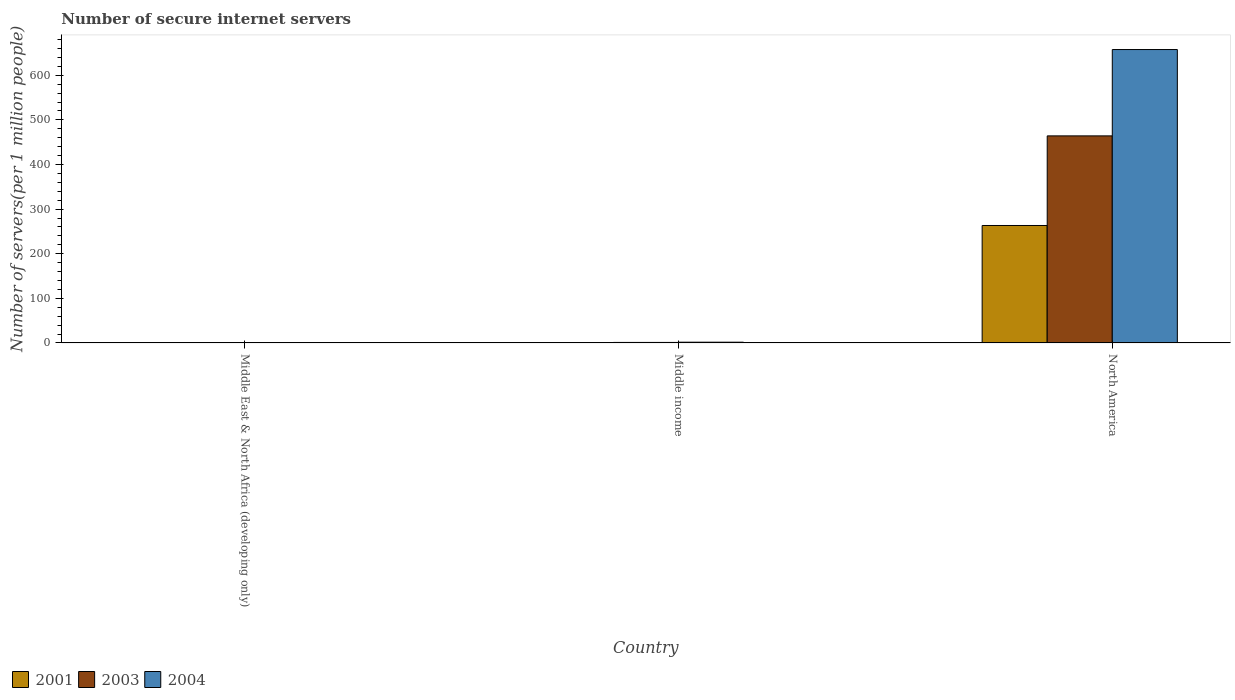What is the label of the 1st group of bars from the left?
Keep it short and to the point. Middle East & North Africa (developing only). In how many cases, is the number of bars for a given country not equal to the number of legend labels?
Your response must be concise. 0. What is the number of secure internet servers in 2004 in North America?
Give a very brief answer. 657.56. Across all countries, what is the maximum number of secure internet servers in 2004?
Offer a terse response. 657.56. Across all countries, what is the minimum number of secure internet servers in 2003?
Offer a terse response. 0.32. In which country was the number of secure internet servers in 2004 maximum?
Make the answer very short. North America. In which country was the number of secure internet servers in 2004 minimum?
Ensure brevity in your answer.  Middle East & North Africa (developing only). What is the total number of secure internet servers in 2001 in the graph?
Your answer should be compact. 264.23. What is the difference between the number of secure internet servers in 2004 in Middle income and that in North America?
Your response must be concise. -655.89. What is the difference between the number of secure internet servers in 2001 in Middle income and the number of secure internet servers in 2003 in North America?
Give a very brief answer. -463.3. What is the average number of secure internet servers in 2003 per country?
Give a very brief answer. 155.18. What is the difference between the number of secure internet servers of/in 2004 and number of secure internet servers of/in 2001 in Middle East & North Africa (developing only)?
Ensure brevity in your answer.  0.37. In how many countries, is the number of secure internet servers in 2004 greater than 200?
Your answer should be compact. 1. What is the ratio of the number of secure internet servers in 2003 in Middle income to that in North America?
Make the answer very short. 0. Is the number of secure internet servers in 2004 in Middle East & North Africa (developing only) less than that in North America?
Make the answer very short. Yes. Is the difference between the number of secure internet servers in 2004 in Middle income and North America greater than the difference between the number of secure internet servers in 2001 in Middle income and North America?
Your answer should be compact. No. What is the difference between the highest and the second highest number of secure internet servers in 2004?
Give a very brief answer. -656.98. What is the difference between the highest and the lowest number of secure internet servers in 2004?
Keep it short and to the point. 656.98. In how many countries, is the number of secure internet servers in 2004 greater than the average number of secure internet servers in 2004 taken over all countries?
Provide a short and direct response. 1. Is the sum of the number of secure internet servers in 2001 in Middle East & North Africa (developing only) and North America greater than the maximum number of secure internet servers in 2004 across all countries?
Offer a very short reply. No. What does the 1st bar from the left in Middle income represents?
Provide a short and direct response. 2001. What does the 1st bar from the right in Middle income represents?
Provide a short and direct response. 2004. How many bars are there?
Your response must be concise. 9. Are the values on the major ticks of Y-axis written in scientific E-notation?
Your answer should be compact. No. How many legend labels are there?
Ensure brevity in your answer.  3. What is the title of the graph?
Your answer should be compact. Number of secure internet servers. What is the label or title of the X-axis?
Keep it short and to the point. Country. What is the label or title of the Y-axis?
Keep it short and to the point. Number of servers(per 1 million people). What is the Number of servers(per 1 million people) in 2001 in Middle East & North Africa (developing only)?
Your response must be concise. 0.21. What is the Number of servers(per 1 million people) of 2003 in Middle East & North Africa (developing only)?
Your answer should be compact. 0.32. What is the Number of servers(per 1 million people) of 2004 in Middle East & North Africa (developing only)?
Your response must be concise. 0.58. What is the Number of servers(per 1 million people) in 2001 in Middle income?
Your answer should be compact. 0.78. What is the Number of servers(per 1 million people) in 2003 in Middle income?
Ensure brevity in your answer.  1.15. What is the Number of servers(per 1 million people) in 2004 in Middle income?
Provide a short and direct response. 1.67. What is the Number of servers(per 1 million people) in 2001 in North America?
Your answer should be very brief. 263.23. What is the Number of servers(per 1 million people) of 2003 in North America?
Keep it short and to the point. 464.07. What is the Number of servers(per 1 million people) of 2004 in North America?
Give a very brief answer. 657.56. Across all countries, what is the maximum Number of servers(per 1 million people) of 2001?
Make the answer very short. 263.23. Across all countries, what is the maximum Number of servers(per 1 million people) of 2003?
Make the answer very short. 464.07. Across all countries, what is the maximum Number of servers(per 1 million people) in 2004?
Ensure brevity in your answer.  657.56. Across all countries, what is the minimum Number of servers(per 1 million people) in 2001?
Your response must be concise. 0.21. Across all countries, what is the minimum Number of servers(per 1 million people) in 2003?
Ensure brevity in your answer.  0.32. Across all countries, what is the minimum Number of servers(per 1 million people) of 2004?
Provide a succinct answer. 0.58. What is the total Number of servers(per 1 million people) in 2001 in the graph?
Your response must be concise. 264.23. What is the total Number of servers(per 1 million people) of 2003 in the graph?
Your response must be concise. 465.54. What is the total Number of servers(per 1 million people) of 2004 in the graph?
Provide a short and direct response. 659.82. What is the difference between the Number of servers(per 1 million people) of 2001 in Middle East & North Africa (developing only) and that in Middle income?
Your answer should be compact. -0.56. What is the difference between the Number of servers(per 1 million people) in 2003 in Middle East & North Africa (developing only) and that in Middle income?
Make the answer very short. -0.83. What is the difference between the Number of servers(per 1 million people) of 2004 in Middle East & North Africa (developing only) and that in Middle income?
Your response must be concise. -1.09. What is the difference between the Number of servers(per 1 million people) in 2001 in Middle East & North Africa (developing only) and that in North America?
Provide a succinct answer. -263.02. What is the difference between the Number of servers(per 1 million people) of 2003 in Middle East & North Africa (developing only) and that in North America?
Keep it short and to the point. -463.76. What is the difference between the Number of servers(per 1 million people) of 2004 in Middle East & North Africa (developing only) and that in North America?
Keep it short and to the point. -656.98. What is the difference between the Number of servers(per 1 million people) of 2001 in Middle income and that in North America?
Provide a succinct answer. -262.46. What is the difference between the Number of servers(per 1 million people) in 2003 in Middle income and that in North America?
Give a very brief answer. -462.93. What is the difference between the Number of servers(per 1 million people) of 2004 in Middle income and that in North America?
Make the answer very short. -655.89. What is the difference between the Number of servers(per 1 million people) of 2001 in Middle East & North Africa (developing only) and the Number of servers(per 1 million people) of 2003 in Middle income?
Your answer should be compact. -0.93. What is the difference between the Number of servers(per 1 million people) in 2001 in Middle East & North Africa (developing only) and the Number of servers(per 1 million people) in 2004 in Middle income?
Provide a succinct answer. -1.46. What is the difference between the Number of servers(per 1 million people) of 2003 in Middle East & North Africa (developing only) and the Number of servers(per 1 million people) of 2004 in Middle income?
Keep it short and to the point. -1.35. What is the difference between the Number of servers(per 1 million people) in 2001 in Middle East & North Africa (developing only) and the Number of servers(per 1 million people) in 2003 in North America?
Keep it short and to the point. -463.86. What is the difference between the Number of servers(per 1 million people) of 2001 in Middle East & North Africa (developing only) and the Number of servers(per 1 million people) of 2004 in North America?
Offer a very short reply. -657.35. What is the difference between the Number of servers(per 1 million people) in 2003 in Middle East & North Africa (developing only) and the Number of servers(per 1 million people) in 2004 in North America?
Provide a short and direct response. -657.25. What is the difference between the Number of servers(per 1 million people) in 2001 in Middle income and the Number of servers(per 1 million people) in 2003 in North America?
Provide a short and direct response. -463.3. What is the difference between the Number of servers(per 1 million people) of 2001 in Middle income and the Number of servers(per 1 million people) of 2004 in North America?
Your answer should be very brief. -656.79. What is the difference between the Number of servers(per 1 million people) of 2003 in Middle income and the Number of servers(per 1 million people) of 2004 in North America?
Offer a very short reply. -656.42. What is the average Number of servers(per 1 million people) in 2001 per country?
Your answer should be compact. 88.08. What is the average Number of servers(per 1 million people) in 2003 per country?
Your response must be concise. 155.18. What is the average Number of servers(per 1 million people) of 2004 per country?
Give a very brief answer. 219.94. What is the difference between the Number of servers(per 1 million people) of 2001 and Number of servers(per 1 million people) of 2003 in Middle East & North Africa (developing only)?
Provide a succinct answer. -0.1. What is the difference between the Number of servers(per 1 million people) of 2001 and Number of servers(per 1 million people) of 2004 in Middle East & North Africa (developing only)?
Ensure brevity in your answer.  -0.37. What is the difference between the Number of servers(per 1 million people) in 2003 and Number of servers(per 1 million people) in 2004 in Middle East & North Africa (developing only)?
Ensure brevity in your answer.  -0.27. What is the difference between the Number of servers(per 1 million people) in 2001 and Number of servers(per 1 million people) in 2003 in Middle income?
Ensure brevity in your answer.  -0.37. What is the difference between the Number of servers(per 1 million people) in 2001 and Number of servers(per 1 million people) in 2004 in Middle income?
Ensure brevity in your answer.  -0.89. What is the difference between the Number of servers(per 1 million people) of 2003 and Number of servers(per 1 million people) of 2004 in Middle income?
Offer a very short reply. -0.52. What is the difference between the Number of servers(per 1 million people) of 2001 and Number of servers(per 1 million people) of 2003 in North America?
Offer a terse response. -200.84. What is the difference between the Number of servers(per 1 million people) of 2001 and Number of servers(per 1 million people) of 2004 in North America?
Your answer should be compact. -394.33. What is the difference between the Number of servers(per 1 million people) of 2003 and Number of servers(per 1 million people) of 2004 in North America?
Ensure brevity in your answer.  -193.49. What is the ratio of the Number of servers(per 1 million people) in 2001 in Middle East & North Africa (developing only) to that in Middle income?
Provide a short and direct response. 0.28. What is the ratio of the Number of servers(per 1 million people) in 2003 in Middle East & North Africa (developing only) to that in Middle income?
Your answer should be very brief. 0.27. What is the ratio of the Number of servers(per 1 million people) of 2004 in Middle East & North Africa (developing only) to that in Middle income?
Your answer should be compact. 0.35. What is the ratio of the Number of servers(per 1 million people) in 2001 in Middle East & North Africa (developing only) to that in North America?
Ensure brevity in your answer.  0. What is the ratio of the Number of servers(per 1 million people) in 2003 in Middle East & North Africa (developing only) to that in North America?
Give a very brief answer. 0. What is the ratio of the Number of servers(per 1 million people) of 2004 in Middle East & North Africa (developing only) to that in North America?
Your response must be concise. 0. What is the ratio of the Number of servers(per 1 million people) in 2001 in Middle income to that in North America?
Your answer should be very brief. 0. What is the ratio of the Number of servers(per 1 million people) of 2003 in Middle income to that in North America?
Your response must be concise. 0. What is the ratio of the Number of servers(per 1 million people) in 2004 in Middle income to that in North America?
Make the answer very short. 0. What is the difference between the highest and the second highest Number of servers(per 1 million people) of 2001?
Your answer should be compact. 262.46. What is the difference between the highest and the second highest Number of servers(per 1 million people) of 2003?
Provide a short and direct response. 462.93. What is the difference between the highest and the second highest Number of servers(per 1 million people) in 2004?
Keep it short and to the point. 655.89. What is the difference between the highest and the lowest Number of servers(per 1 million people) of 2001?
Provide a short and direct response. 263.02. What is the difference between the highest and the lowest Number of servers(per 1 million people) in 2003?
Offer a terse response. 463.76. What is the difference between the highest and the lowest Number of servers(per 1 million people) of 2004?
Offer a very short reply. 656.98. 